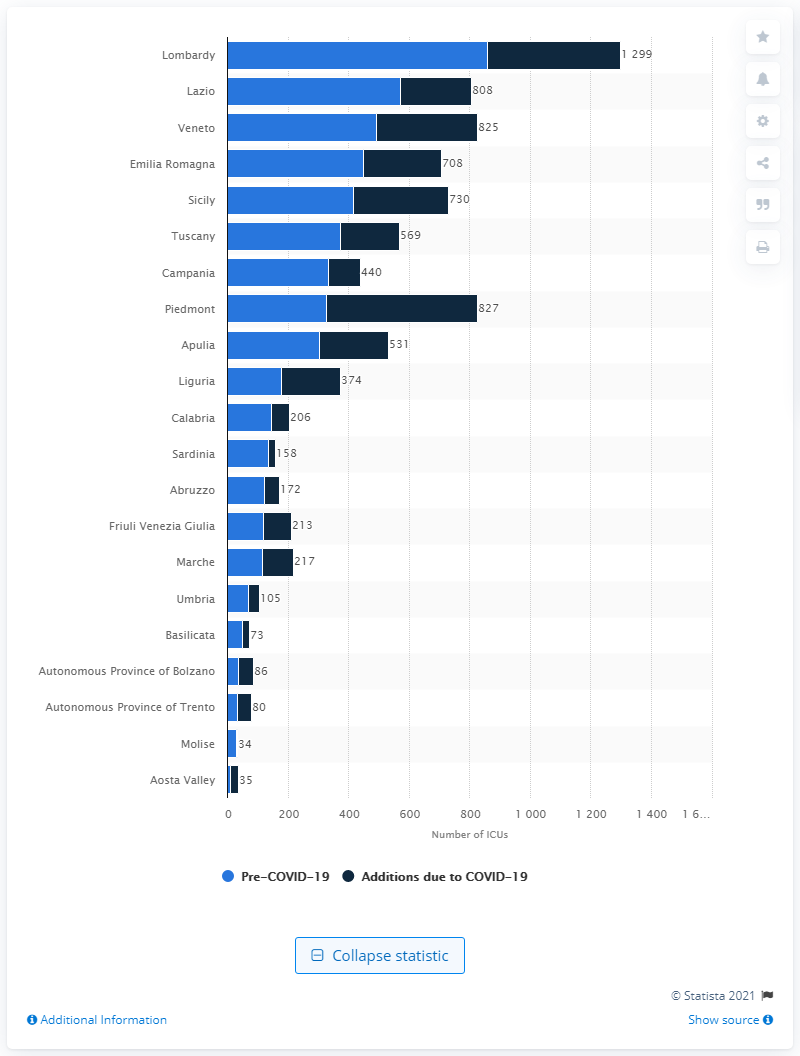Give some essential details in this illustration. The region with the highest number of ICUs in Italy is Lombardy. 